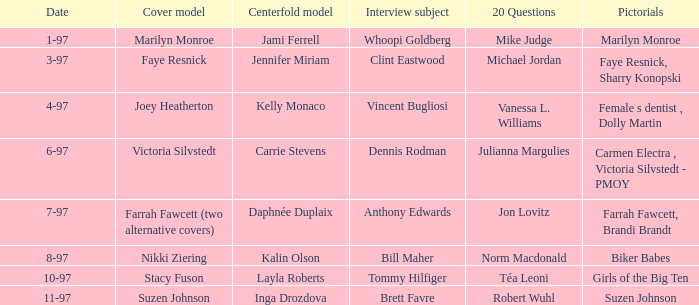Who was the interviewee on the date 1-97? Whoopi Goldberg. 